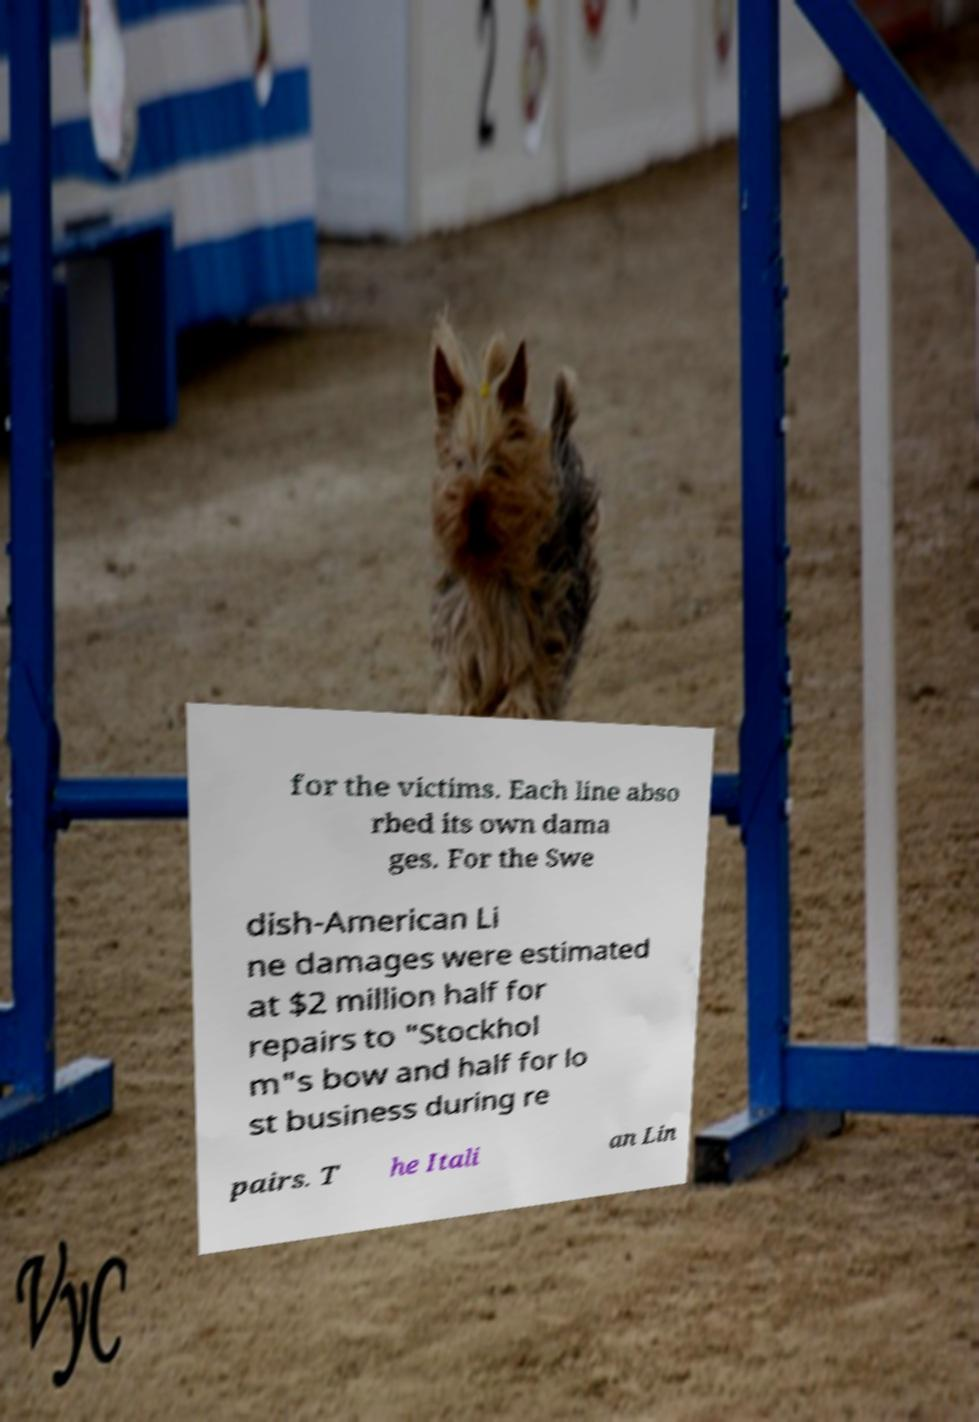Can you read and provide the text displayed in the image?This photo seems to have some interesting text. Can you extract and type it out for me? for the victims. Each line abso rbed its own dama ges. For the Swe dish-American Li ne damages were estimated at $2 million half for repairs to "Stockhol m"s bow and half for lo st business during re pairs. T he Itali an Lin 